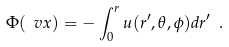Convert formula to latex. <formula><loc_0><loc_0><loc_500><loc_500>\Phi ( \ v x ) = - \int _ { 0 } ^ { r } u ( r ^ { \prime } , \theta , \phi ) d r ^ { \prime } \ .</formula> 